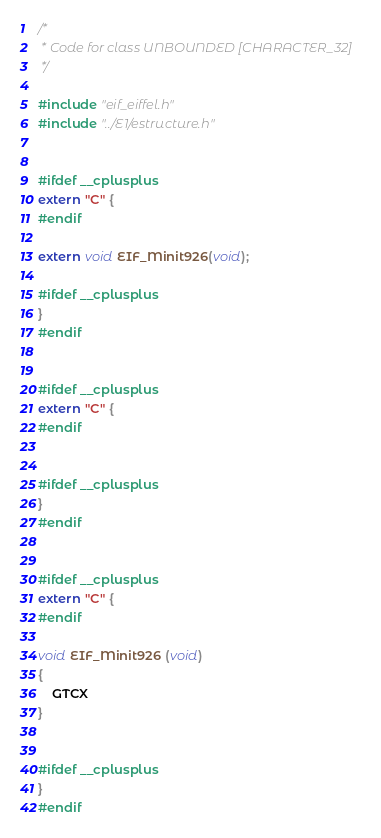Convert code to text. <code><loc_0><loc_0><loc_500><loc_500><_C_>/*
 * Code for class UNBOUNDED [CHARACTER_32]
 */

#include "eif_eiffel.h"
#include "../E1/estructure.h"


#ifdef __cplusplus
extern "C" {
#endif

extern void EIF_Minit926(void);

#ifdef __cplusplus
}
#endif


#ifdef __cplusplus
extern "C" {
#endif


#ifdef __cplusplus
}
#endif


#ifdef __cplusplus
extern "C" {
#endif

void EIF_Minit926 (void)
{
	GTCX
}


#ifdef __cplusplus
}
#endif
</code> 